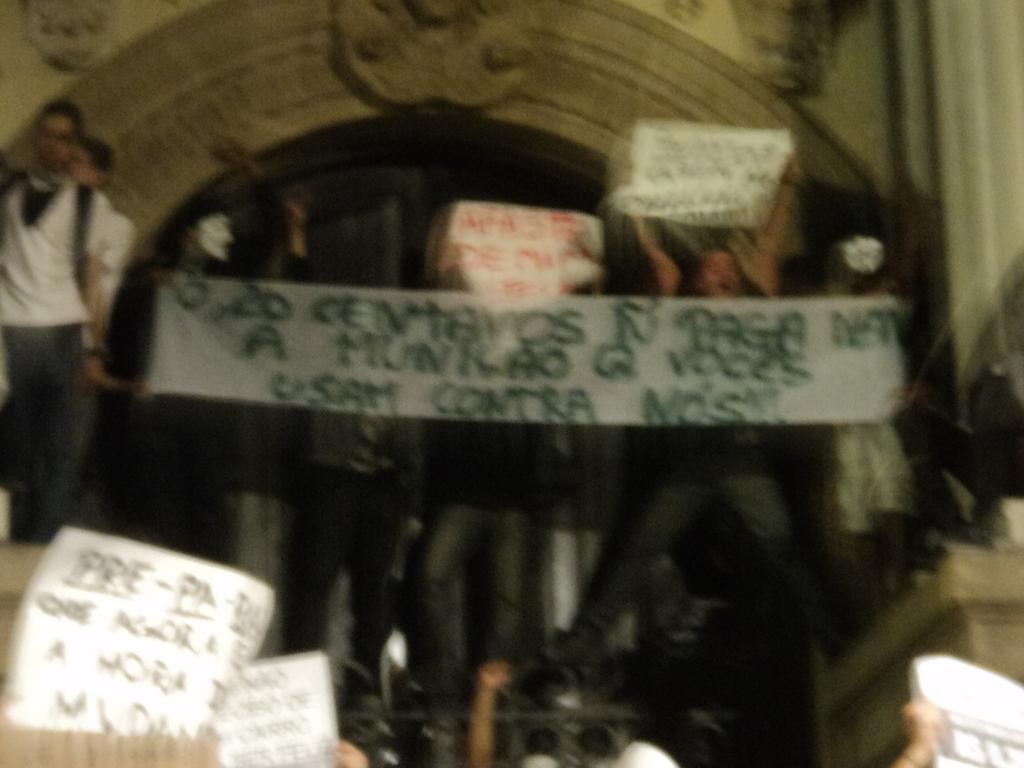How many people are in the image? There is a group of people in the image, but the exact number is not specified. What are some people doing in the image? Some people are holding banners in the image. What can be seen in the background of the image? There is a wall in the image, and carvings are present on the wall. What type of dress is the tiger wearing in the image? There is no tiger present in the image, and therefore no dress or any other clothing item can be attributed to it. 